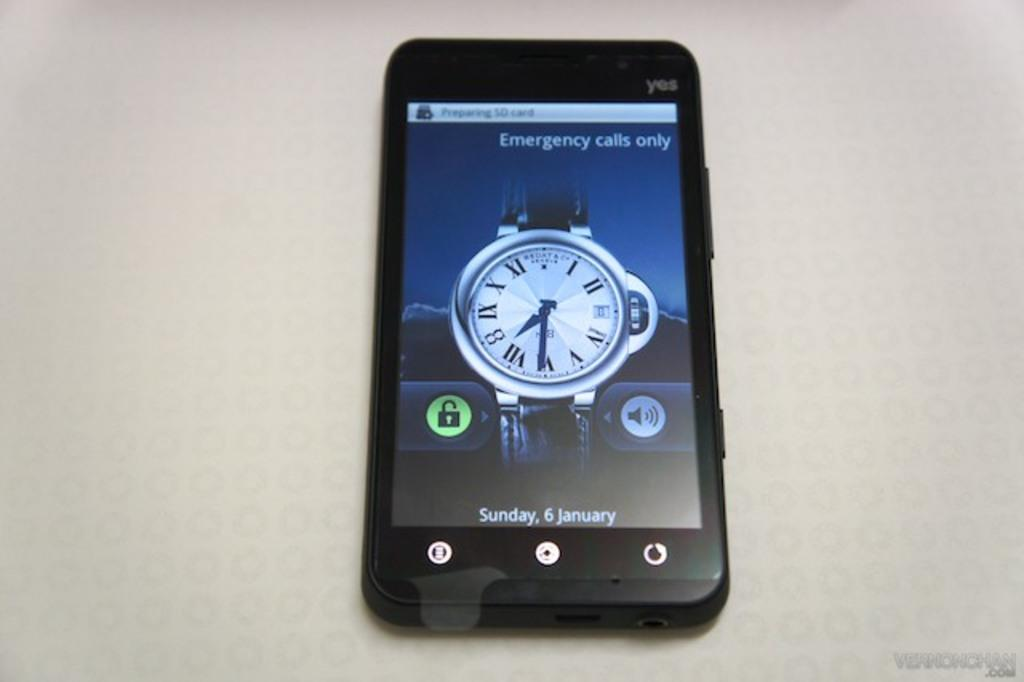<image>
Render a clear and concise summary of the photo. A phone screen says "emergency calls only" at the top. 